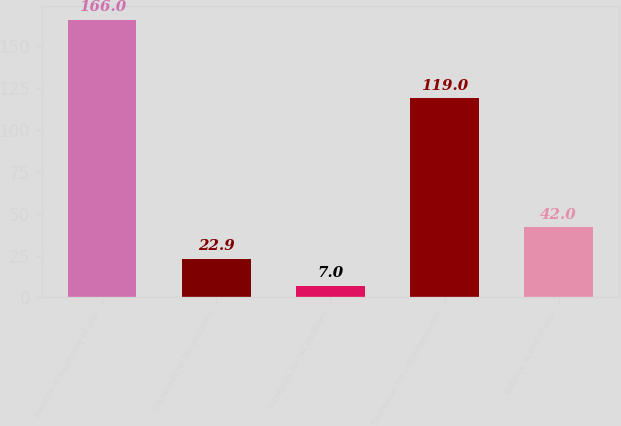<chart> <loc_0><loc_0><loc_500><loc_500><bar_chart><fcel>Balance at beginning of year<fcel>Decreases for tax positions<fcel>Increases for tax positions<fcel>Decreases for settlements with<fcel>Balance at end of year<nl><fcel>166<fcel>22.9<fcel>7<fcel>119<fcel>42<nl></chart> 